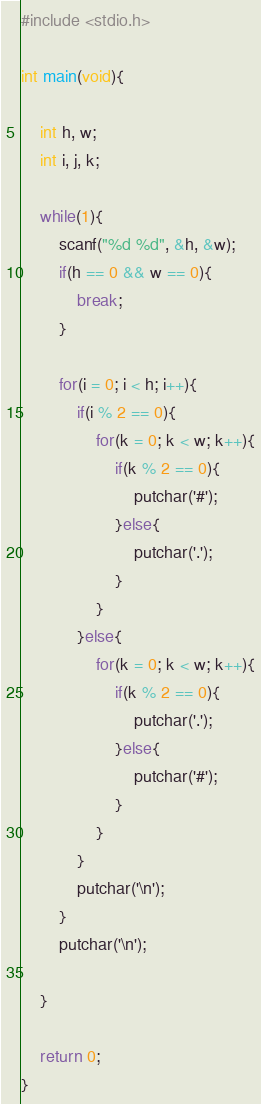<code> <loc_0><loc_0><loc_500><loc_500><_C_>#include <stdio.h>

int main(void){

	int h, w;
	int i, j, k;
	
	while(1){
		scanf("%d %d", &h, &w);
		if(h == 0 && w == 0){
			break;
		}
		
		for(i = 0; i < h; i++){
			if(i % 2 == 0){
				for(k = 0; k < w; k++){
					if(k % 2 == 0){
						putchar('#');
					}else{
						putchar('.');
					}
				}
			}else{
				for(k = 0; k < w; k++){
					if(k % 2 == 0){
						putchar('.');
					}else{
						putchar('#');
					}
				}
			}
			putchar('\n');
		}
		putchar('\n');
	
	}
	
	return 0;
}</code> 